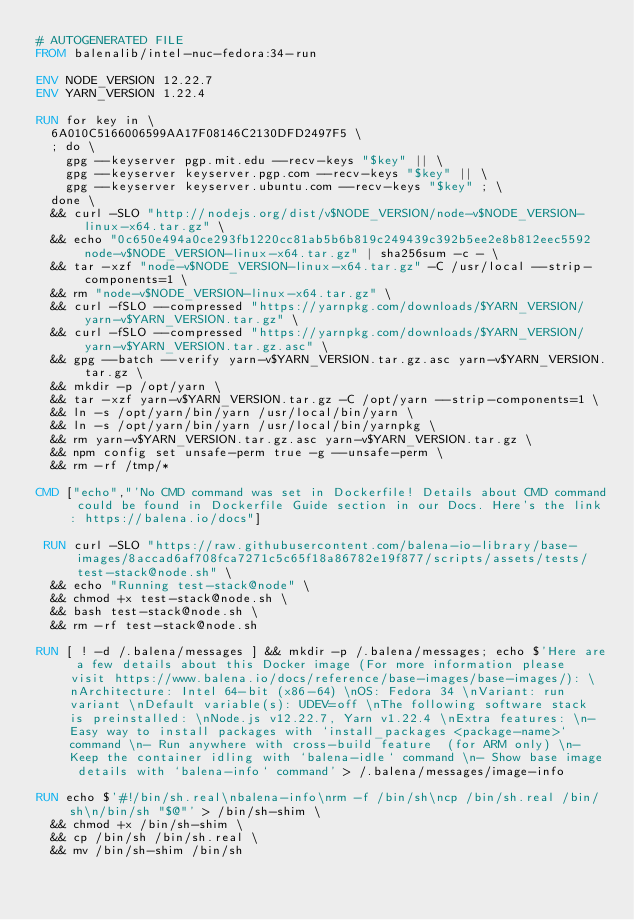<code> <loc_0><loc_0><loc_500><loc_500><_Dockerfile_># AUTOGENERATED FILE
FROM balenalib/intel-nuc-fedora:34-run

ENV NODE_VERSION 12.22.7
ENV YARN_VERSION 1.22.4

RUN for key in \
	6A010C5166006599AA17F08146C2130DFD2497F5 \
	; do \
		gpg --keyserver pgp.mit.edu --recv-keys "$key" || \
		gpg --keyserver keyserver.pgp.com --recv-keys "$key" || \
		gpg --keyserver keyserver.ubuntu.com --recv-keys "$key" ; \
	done \
	&& curl -SLO "http://nodejs.org/dist/v$NODE_VERSION/node-v$NODE_VERSION-linux-x64.tar.gz" \
	&& echo "0c650e494a0ce293fb1220cc81ab5b6b819c249439c392b5ee2e8b812eec5592  node-v$NODE_VERSION-linux-x64.tar.gz" | sha256sum -c - \
	&& tar -xzf "node-v$NODE_VERSION-linux-x64.tar.gz" -C /usr/local --strip-components=1 \
	&& rm "node-v$NODE_VERSION-linux-x64.tar.gz" \
	&& curl -fSLO --compressed "https://yarnpkg.com/downloads/$YARN_VERSION/yarn-v$YARN_VERSION.tar.gz" \
	&& curl -fSLO --compressed "https://yarnpkg.com/downloads/$YARN_VERSION/yarn-v$YARN_VERSION.tar.gz.asc" \
	&& gpg --batch --verify yarn-v$YARN_VERSION.tar.gz.asc yarn-v$YARN_VERSION.tar.gz \
	&& mkdir -p /opt/yarn \
	&& tar -xzf yarn-v$YARN_VERSION.tar.gz -C /opt/yarn --strip-components=1 \
	&& ln -s /opt/yarn/bin/yarn /usr/local/bin/yarn \
	&& ln -s /opt/yarn/bin/yarn /usr/local/bin/yarnpkg \
	&& rm yarn-v$YARN_VERSION.tar.gz.asc yarn-v$YARN_VERSION.tar.gz \
	&& npm config set unsafe-perm true -g --unsafe-perm \
	&& rm -rf /tmp/*

CMD ["echo","'No CMD command was set in Dockerfile! Details about CMD command could be found in Dockerfile Guide section in our Docs. Here's the link: https://balena.io/docs"]

 RUN curl -SLO "https://raw.githubusercontent.com/balena-io-library/base-images/8accad6af708fca7271c5c65f18a86782e19f877/scripts/assets/tests/test-stack@node.sh" \
  && echo "Running test-stack@node" \
  && chmod +x test-stack@node.sh \
  && bash test-stack@node.sh \
  && rm -rf test-stack@node.sh 

RUN [ ! -d /.balena/messages ] && mkdir -p /.balena/messages; echo $'Here are a few details about this Docker image (For more information please visit https://www.balena.io/docs/reference/base-images/base-images/): \nArchitecture: Intel 64-bit (x86-64) \nOS: Fedora 34 \nVariant: run variant \nDefault variable(s): UDEV=off \nThe following software stack is preinstalled: \nNode.js v12.22.7, Yarn v1.22.4 \nExtra features: \n- Easy way to install packages with `install_packages <package-name>` command \n- Run anywhere with cross-build feature  (for ARM only) \n- Keep the container idling with `balena-idle` command \n- Show base image details with `balena-info` command' > /.balena/messages/image-info

RUN echo $'#!/bin/sh.real\nbalena-info\nrm -f /bin/sh\ncp /bin/sh.real /bin/sh\n/bin/sh "$@"' > /bin/sh-shim \
	&& chmod +x /bin/sh-shim \
	&& cp /bin/sh /bin/sh.real \
	&& mv /bin/sh-shim /bin/sh</code> 